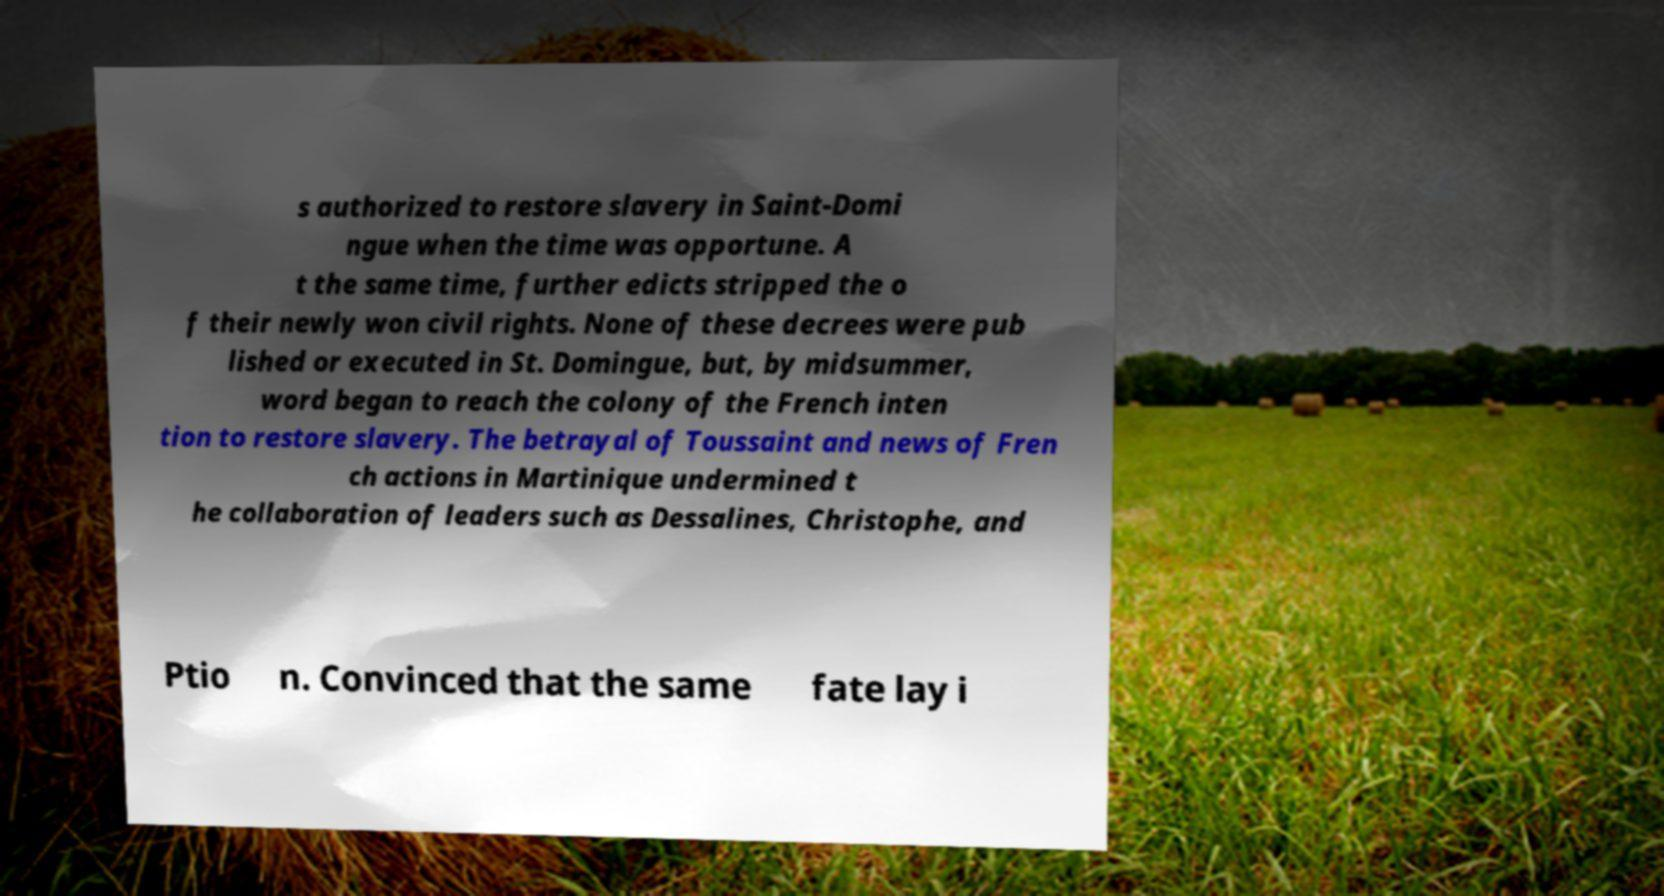Can you accurately transcribe the text from the provided image for me? s authorized to restore slavery in Saint-Domi ngue when the time was opportune. A t the same time, further edicts stripped the o f their newly won civil rights. None of these decrees were pub lished or executed in St. Domingue, but, by midsummer, word began to reach the colony of the French inten tion to restore slavery. The betrayal of Toussaint and news of Fren ch actions in Martinique undermined t he collaboration of leaders such as Dessalines, Christophe, and Ptio n. Convinced that the same fate lay i 